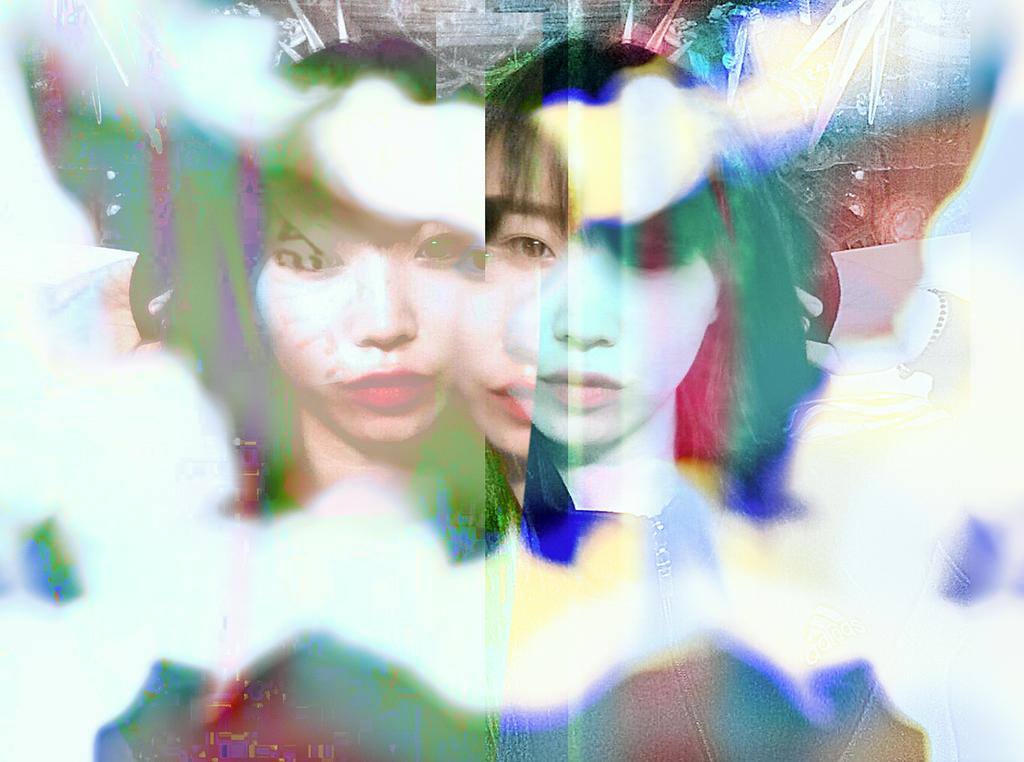What type of image is being described? The image is an edited picture. What is the main subject of the image? There is a woman's face in the center of the image. What feature of the woman's face is mentioned? The woman's face has reflections. What type of square appliance can be seen in the image? There is no square appliance present in the image; it features a woman's face with reflections. What is the monetary value of the woman's face in the image? The image does not provide any information about the monetary value of the woman's face. 